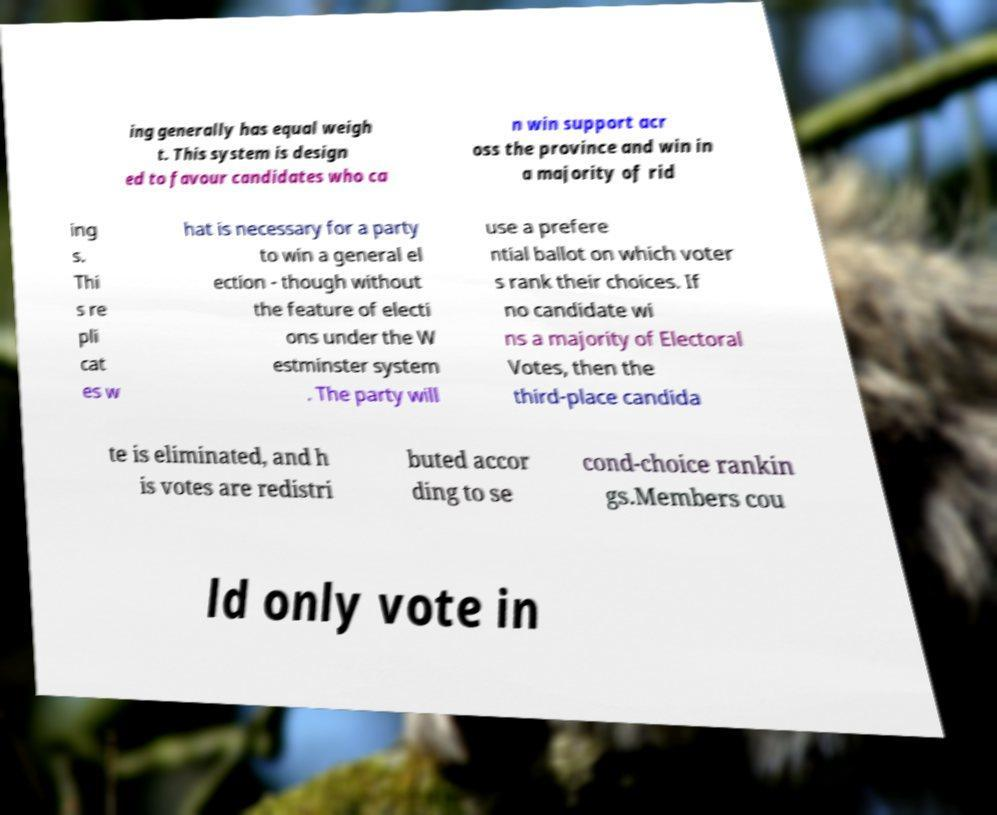There's text embedded in this image that I need extracted. Can you transcribe it verbatim? ing generally has equal weigh t. This system is design ed to favour candidates who ca n win support acr oss the province and win in a majority of rid ing s. Thi s re pli cat es w hat is necessary for a party to win a general el ection - though without the feature of electi ons under the W estminster system . The party will use a prefere ntial ballot on which voter s rank their choices. If no candidate wi ns a majority of Electoral Votes, then the third-place candida te is eliminated, and h is votes are redistri buted accor ding to se cond-choice rankin gs.Members cou ld only vote in 